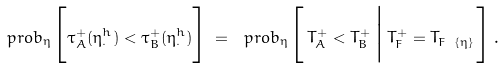<formula> <loc_0><loc_0><loc_500><loc_500>\ p r o b _ { \eta } \Big [ \tau ^ { + } _ { A } ( \eta ^ { h } _ { \cdot } ) < \tau ^ { + } _ { B } ( \eta ^ { h } _ { \cdot } ) \Big ] \, = \, \ p r o b _ { \eta } \Big [ \, T ^ { + } _ { A } < T ^ { + } _ { B } \, \Big | \, T ^ { + } _ { F } = T _ { F \ \{ \eta \} } \, \Big ] \, .</formula> 